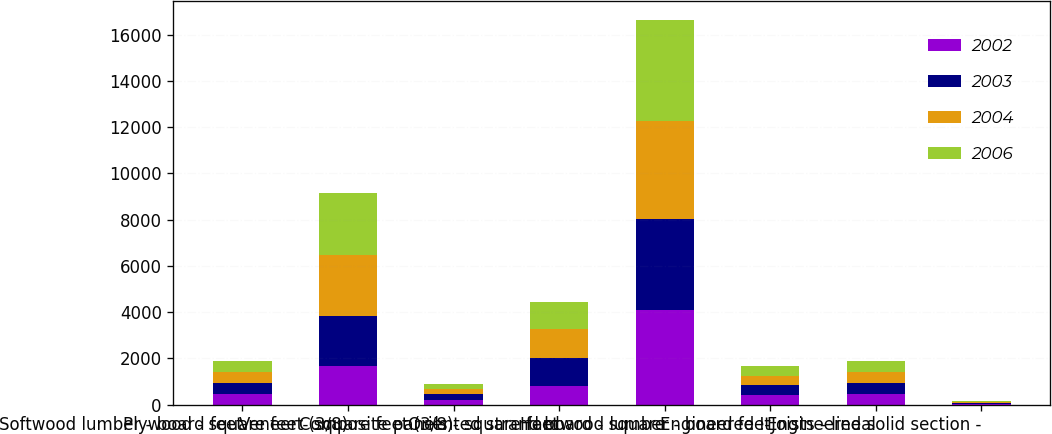<chart> <loc_0><loc_0><loc_500><loc_500><stacked_bar_chart><ecel><fcel>Softwood lumber - board feet<fcel>Plywood - square feet (3/8)<fcel>Veneer - square feet (3/8)<fcel>Composite panels - square feet<fcel>Oriented strand board - square<fcel>Hardwood lumber - board feet<fcel>Engineered I-Joists - lineal<fcel>Engineered solid section -<nl><fcel>2002<fcel>470<fcel>1663<fcel>215<fcel>802<fcel>4096<fcel>412<fcel>456<fcel>36<nl><fcel>2003<fcel>470<fcel>2180<fcel>231<fcel>1229<fcel>3948<fcel>427<fcel>484<fcel>38<nl><fcel>2004<fcel>470<fcel>2629<fcel>225<fcel>1234<fcel>4213<fcel>417<fcel>496<fcel>37<nl><fcel>2006<fcel>470<fcel>2665<fcel>239<fcel>1162<fcel>4361<fcel>435<fcel>447<fcel>32<nl></chart> 